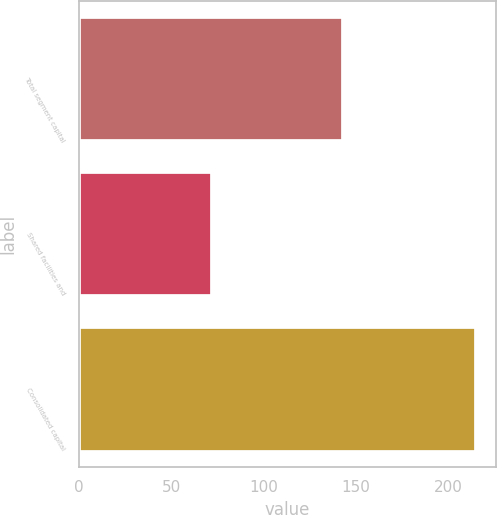Convert chart. <chart><loc_0><loc_0><loc_500><loc_500><bar_chart><fcel>Total segment capital<fcel>Shared facilities and<fcel>Consolidated capital<nl><fcel>143<fcel>72<fcel>215<nl></chart> 